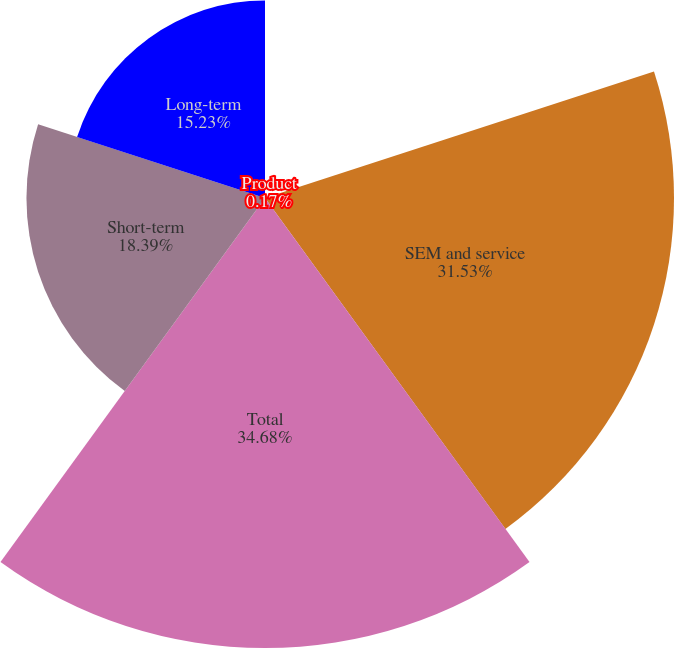<chart> <loc_0><loc_0><loc_500><loc_500><pie_chart><fcel>Product<fcel>SEM and service<fcel>Total<fcel>Short-term<fcel>Long-term<nl><fcel>0.17%<fcel>31.53%<fcel>34.69%<fcel>18.39%<fcel>15.23%<nl></chart> 